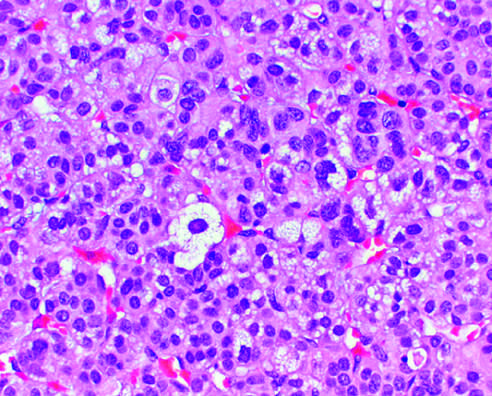what are vacuolated because of the presence of intracytoplasmic lipid?
Answer the question using a single word or phrase. The neoplastic cells 